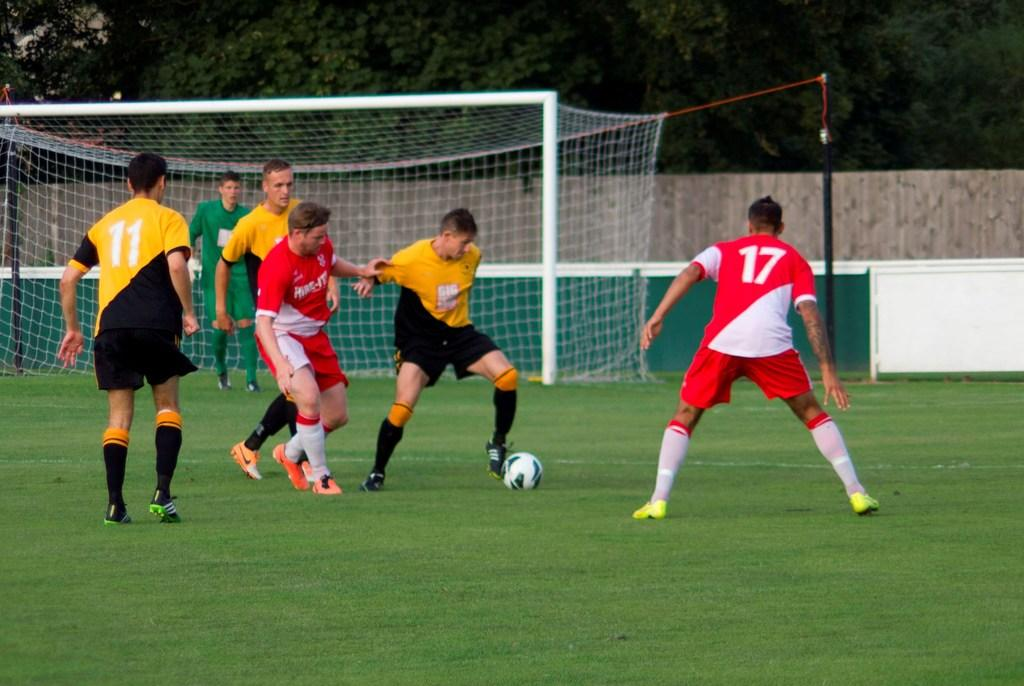<image>
Describe the image concisely. Player number 17 is watching the player with the soccer ball. 